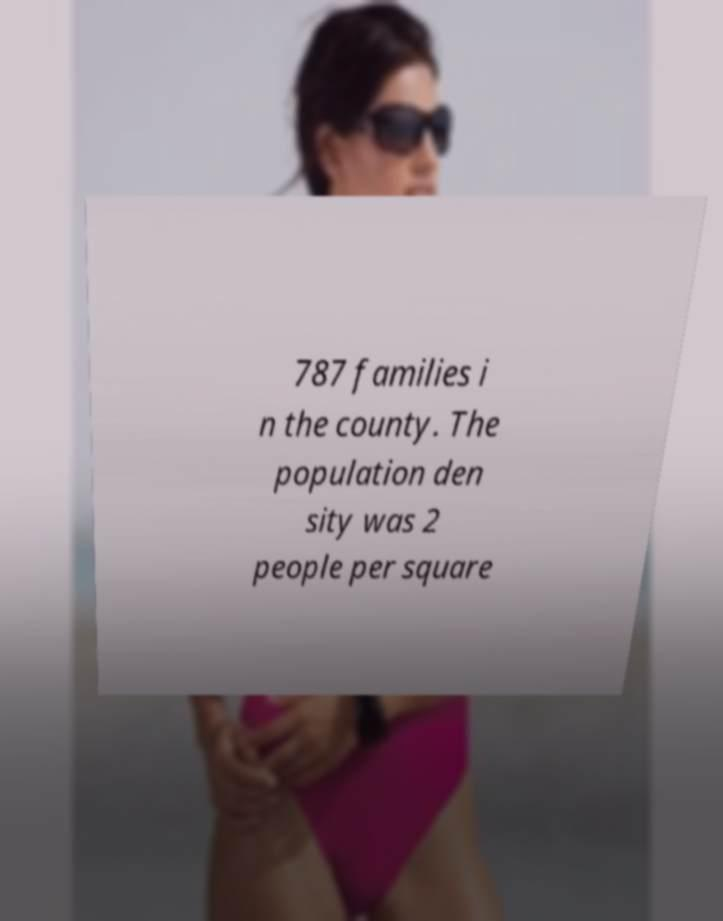Could you extract and type out the text from this image? 787 families i n the county. The population den sity was 2 people per square 